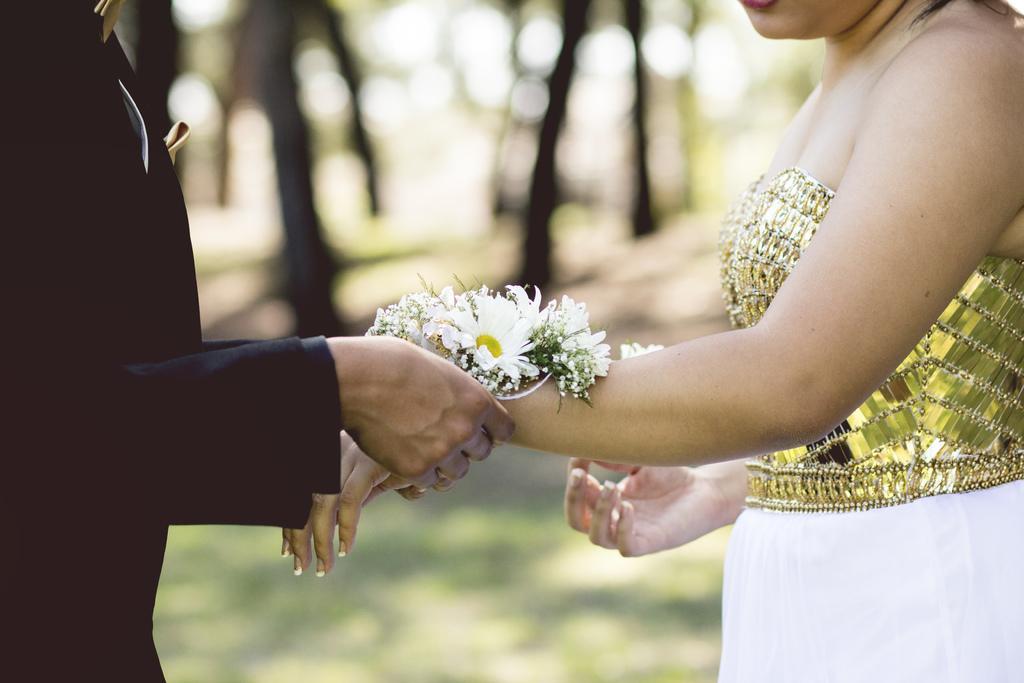How would you summarize this image in a sentence or two? There is one man standing and wearing a black color dress and holding a hand of a woman, and the woman is wearing gold and white color dress. It seems like there are some trees in the background. 